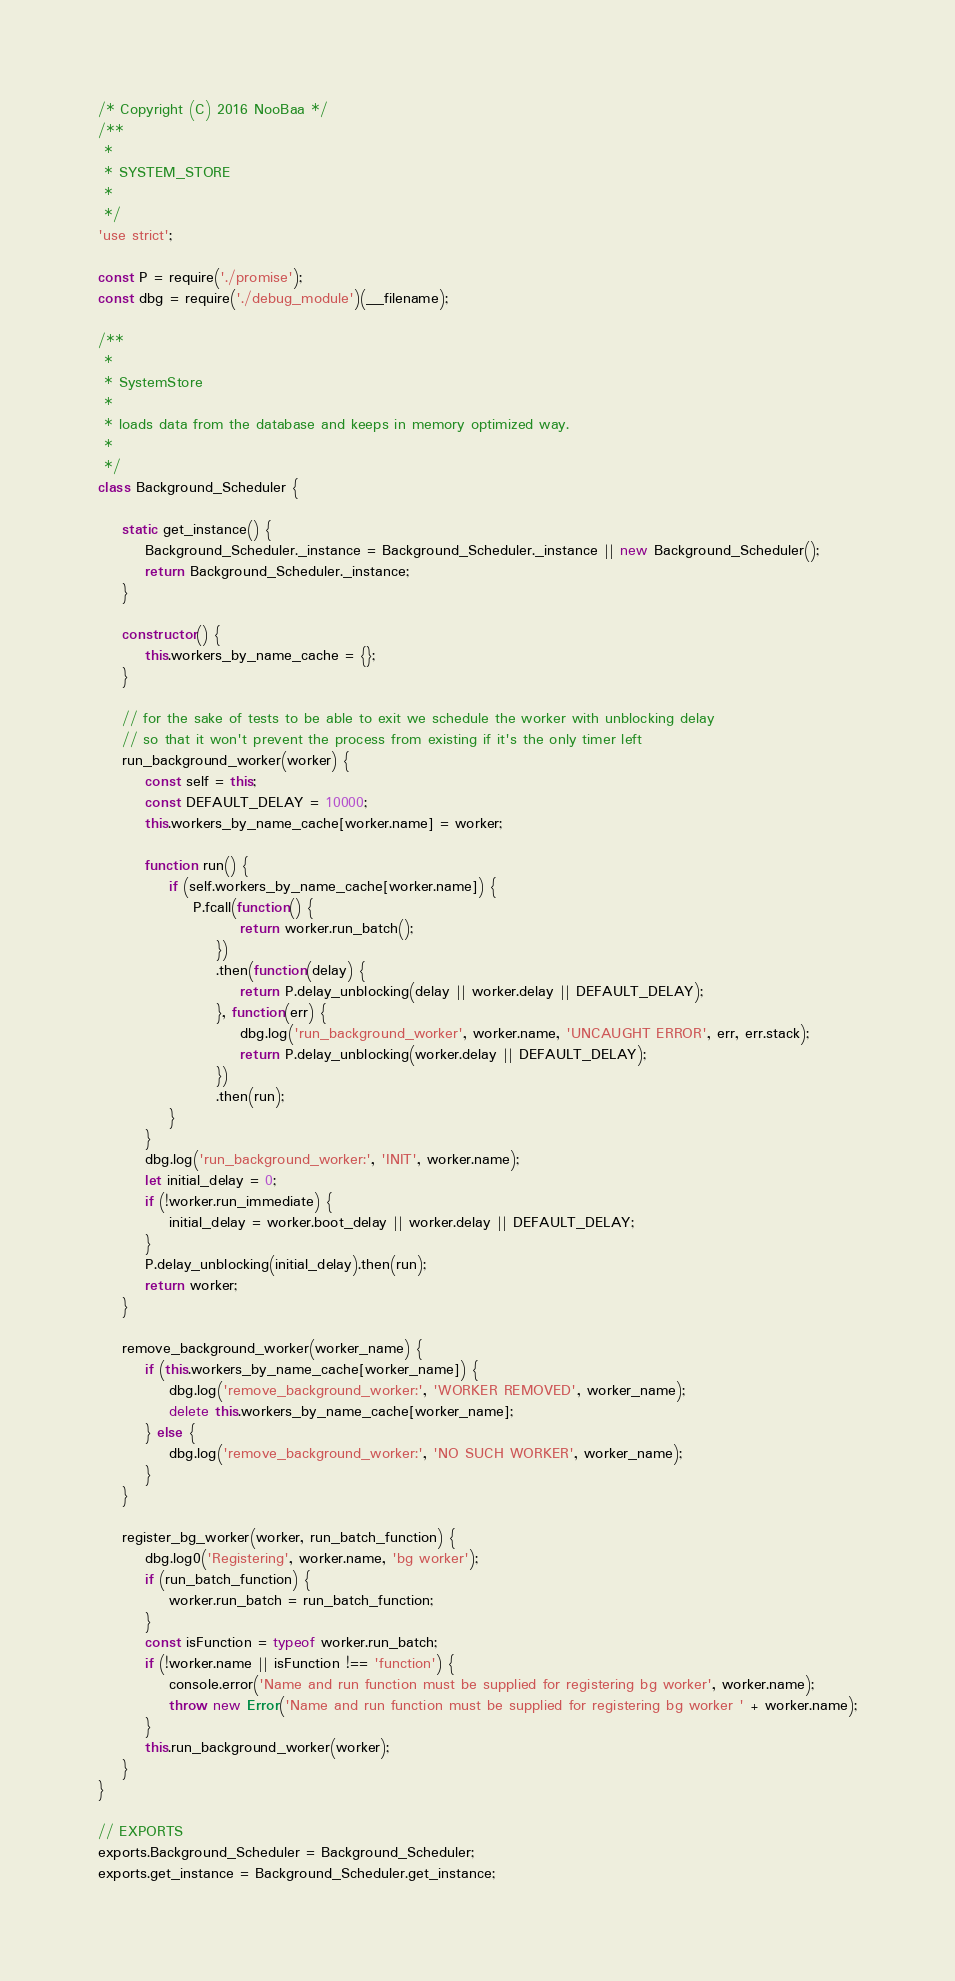<code> <loc_0><loc_0><loc_500><loc_500><_JavaScript_>/* Copyright (C) 2016 NooBaa */
/**
 *
 * SYSTEM_STORE
 *
 */
'use strict';

const P = require('./promise');
const dbg = require('./debug_module')(__filename);

/**
 *
 * SystemStore
 *
 * loads data from the database and keeps in memory optimized way.
 *
 */
class Background_Scheduler {

    static get_instance() {
        Background_Scheduler._instance = Background_Scheduler._instance || new Background_Scheduler();
        return Background_Scheduler._instance;
    }

    constructor() {
        this.workers_by_name_cache = {};
    }

    // for the sake of tests to be able to exit we schedule the worker with unblocking delay
    // so that it won't prevent the process from existing if it's the only timer left
    run_background_worker(worker) {
        const self = this;
        const DEFAULT_DELAY = 10000;
        this.workers_by_name_cache[worker.name] = worker;

        function run() {
            if (self.workers_by_name_cache[worker.name]) {
                P.fcall(function() {
                        return worker.run_batch();
                    })
                    .then(function(delay) {
                        return P.delay_unblocking(delay || worker.delay || DEFAULT_DELAY);
                    }, function(err) {
                        dbg.log('run_background_worker', worker.name, 'UNCAUGHT ERROR', err, err.stack);
                        return P.delay_unblocking(worker.delay || DEFAULT_DELAY);
                    })
                    .then(run);
            }
        }
        dbg.log('run_background_worker:', 'INIT', worker.name);
        let initial_delay = 0;
        if (!worker.run_immediate) {
            initial_delay = worker.boot_delay || worker.delay || DEFAULT_DELAY;
        }
        P.delay_unblocking(initial_delay).then(run);
        return worker;
    }

    remove_background_worker(worker_name) {
        if (this.workers_by_name_cache[worker_name]) {
            dbg.log('remove_background_worker:', 'WORKER REMOVED', worker_name);
            delete this.workers_by_name_cache[worker_name];
        } else {
            dbg.log('remove_background_worker:', 'NO SUCH WORKER', worker_name);
        }
    }

    register_bg_worker(worker, run_batch_function) {
        dbg.log0('Registering', worker.name, 'bg worker');
        if (run_batch_function) {
            worker.run_batch = run_batch_function;
        }
        const isFunction = typeof worker.run_batch;
        if (!worker.name || isFunction !== 'function') {
            console.error('Name and run function must be supplied for registering bg worker', worker.name);
            throw new Error('Name and run function must be supplied for registering bg worker ' + worker.name);
        }
        this.run_background_worker(worker);
    }
}

// EXPORTS
exports.Background_Scheduler = Background_Scheduler;
exports.get_instance = Background_Scheduler.get_instance;
</code> 